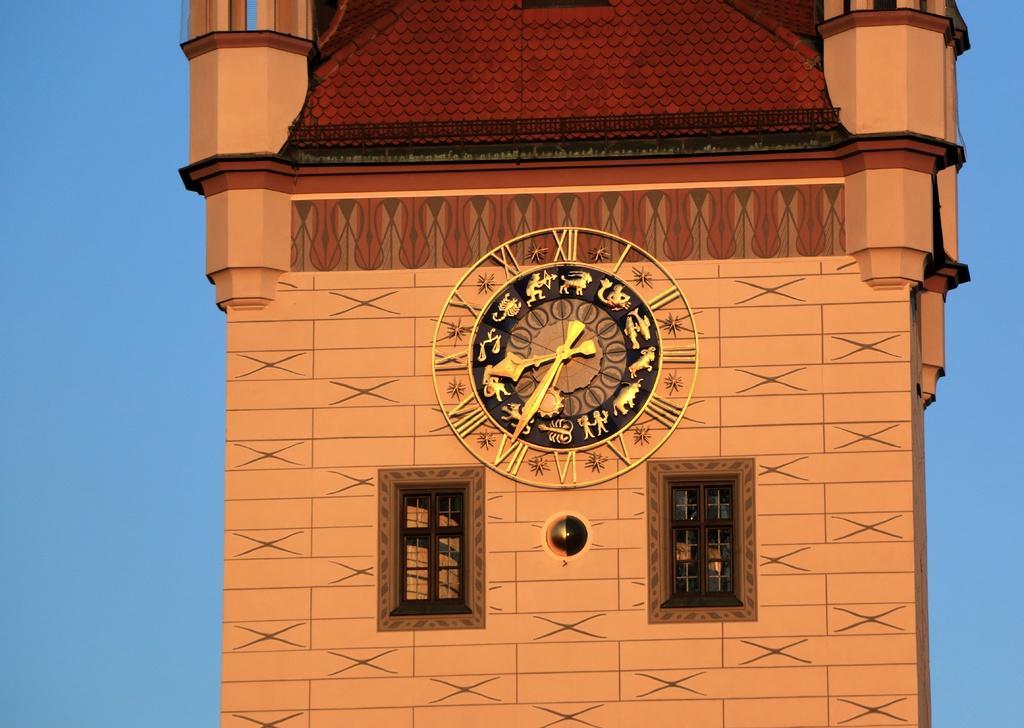How would you summarize this image in a sentence or two? In this picture I can see a painting of clock and a building. Here I can see two windows. The background of the image is blue in color. 